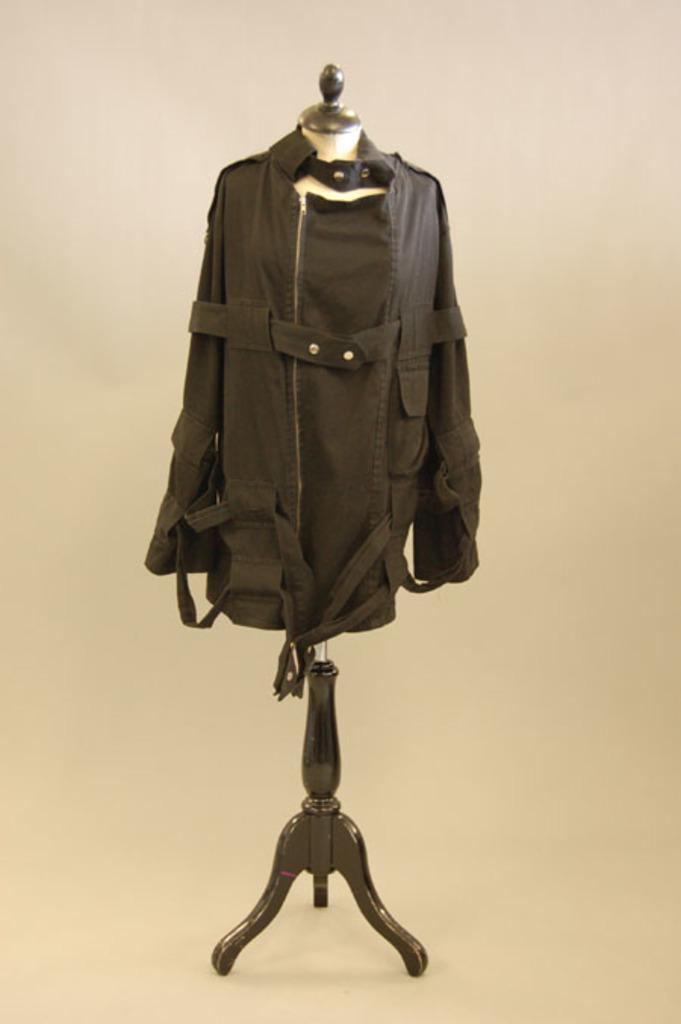Can you describe this image briefly? In this image I can see a coat is there to the doll hanger. 